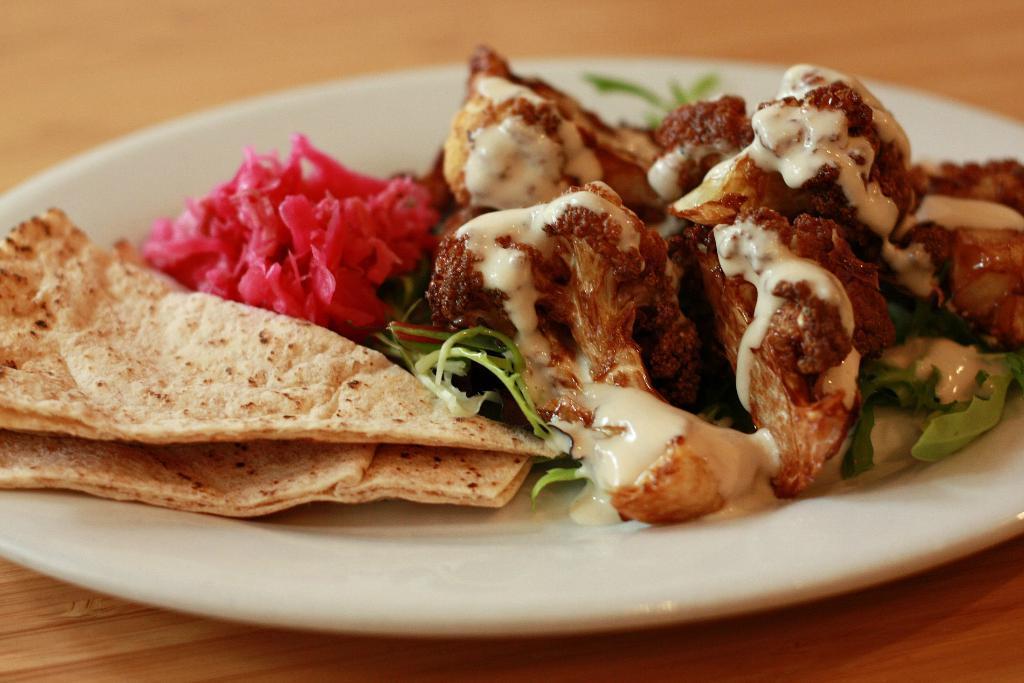Please provide a concise description of this image. In this image we can see a food item kept on the plate which is placed on the wooden table. 